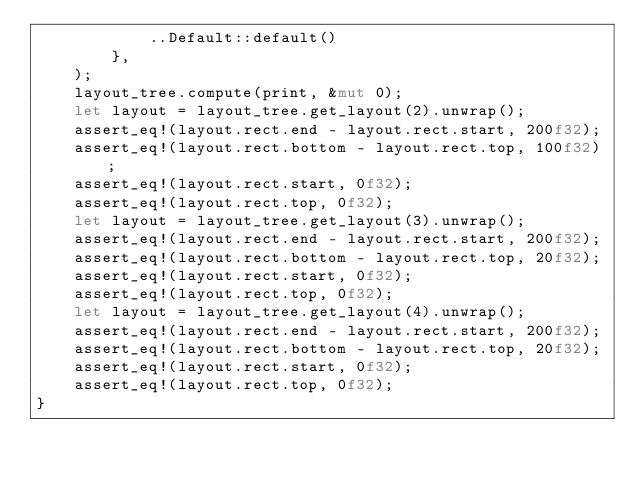<code> <loc_0><loc_0><loc_500><loc_500><_Rust_>            ..Default::default()
        },
    );
    layout_tree.compute(print, &mut 0);
    let layout = layout_tree.get_layout(2).unwrap();
    assert_eq!(layout.rect.end - layout.rect.start, 200f32);
    assert_eq!(layout.rect.bottom - layout.rect.top, 100f32);
    assert_eq!(layout.rect.start, 0f32);
    assert_eq!(layout.rect.top, 0f32);
    let layout = layout_tree.get_layout(3).unwrap();
    assert_eq!(layout.rect.end - layout.rect.start, 200f32);
    assert_eq!(layout.rect.bottom - layout.rect.top, 20f32);
    assert_eq!(layout.rect.start, 0f32);
    assert_eq!(layout.rect.top, 0f32);
    let layout = layout_tree.get_layout(4).unwrap();
    assert_eq!(layout.rect.end - layout.rect.start, 200f32);
    assert_eq!(layout.rect.bottom - layout.rect.top, 20f32);
    assert_eq!(layout.rect.start, 0f32);
    assert_eq!(layout.rect.top, 0f32);
}
</code> 